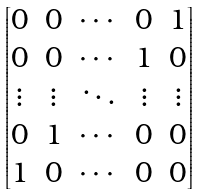<formula> <loc_0><loc_0><loc_500><loc_500>\begin{bmatrix} 0 & 0 & \cdots & 0 & 1 \\ 0 & 0 & \cdots & 1 & 0 \\ \vdots & \vdots & \ddots & \vdots & \vdots \\ 0 & 1 & \cdots & 0 & 0 \\ 1 & 0 & \cdots & 0 & 0 \end{bmatrix}</formula> 